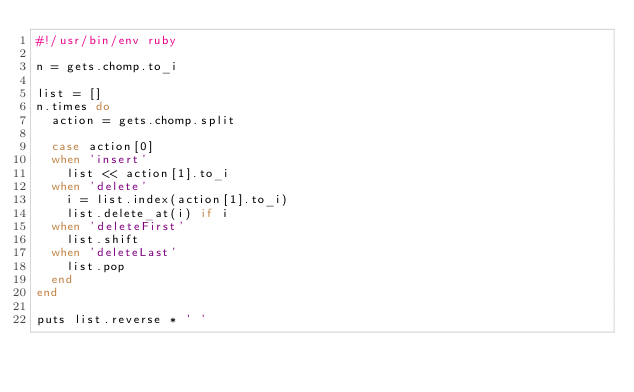<code> <loc_0><loc_0><loc_500><loc_500><_Ruby_>#!/usr/bin/env ruby

n = gets.chomp.to_i

list = []
n.times do
  action = gets.chomp.split

  case action[0]
  when 'insert'
    list << action[1].to_i
  when 'delete'
    i = list.index(action[1].to_i)
    list.delete_at(i) if i
  when 'deleteFirst'
    list.shift
  when 'deleteLast'
    list.pop
  end
end

puts list.reverse * ' '</code> 